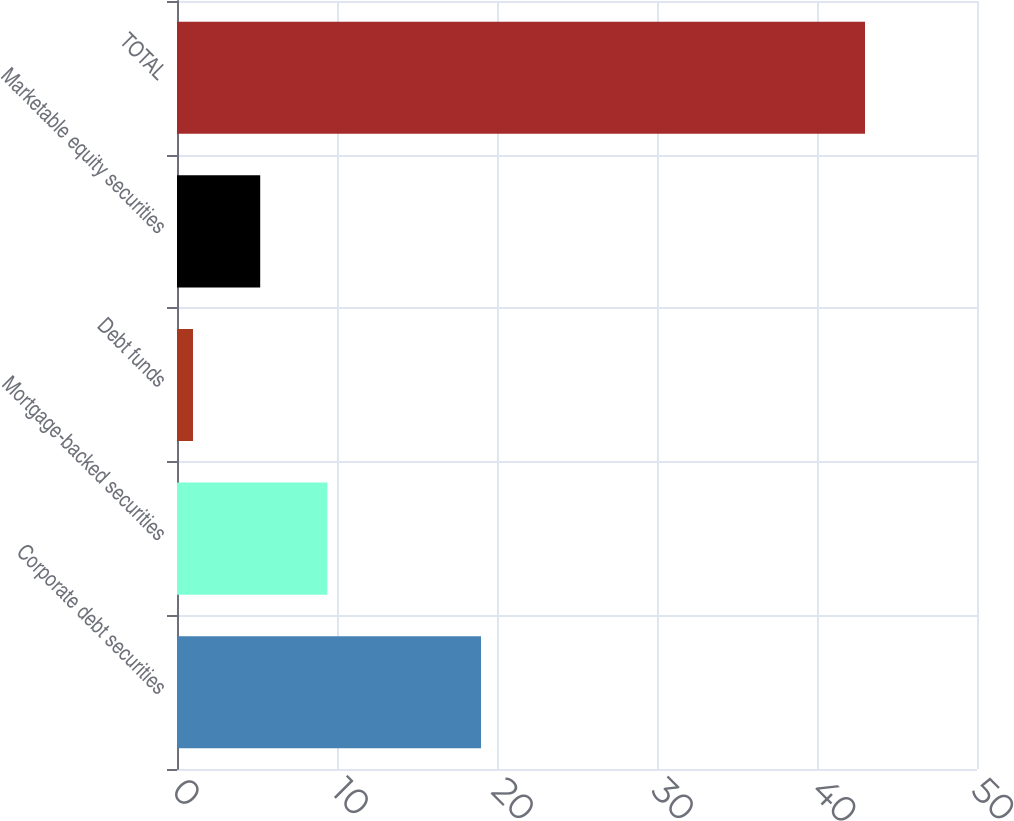Convert chart. <chart><loc_0><loc_0><loc_500><loc_500><bar_chart><fcel>Corporate debt securities<fcel>Mortgage-backed securities<fcel>Debt funds<fcel>Marketable equity securities<fcel>TOTAL<nl><fcel>19<fcel>9.4<fcel>1<fcel>5.2<fcel>43<nl></chart> 